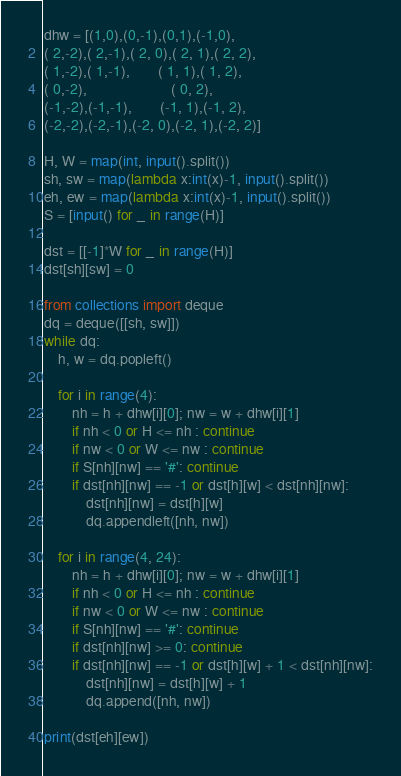Convert code to text. <code><loc_0><loc_0><loc_500><loc_500><_Python_>dhw = [(1,0),(0,-1),(0,1),(-1,0),
( 2,-2),( 2,-1),( 2, 0),( 2, 1),( 2, 2),
( 1,-2),( 1,-1),        ( 1, 1),( 1, 2),
( 0,-2),                        ( 0, 2),
(-1,-2),(-1,-1),        (-1, 1),(-1, 2),
(-2,-2),(-2,-1),(-2, 0),(-2, 1),(-2, 2)]

H, W = map(int, input().split())
sh, sw = map(lambda x:int(x)-1, input().split())
eh, ew = map(lambda x:int(x)-1, input().split())
S = [input() for _ in range(H)]

dst = [[-1]*W for _ in range(H)]
dst[sh][sw] = 0

from collections import deque
dq = deque([[sh, sw]])
while dq:
    h, w = dq.popleft()

    for i in range(4):
        nh = h + dhw[i][0]; nw = w + dhw[i][1]
        if nh < 0 or H <= nh : continue
        if nw < 0 or W <= nw : continue
        if S[nh][nw] == '#': continue
        if dst[nh][nw] == -1 or dst[h][w] < dst[nh][nw]:
            dst[nh][nw] = dst[h][w]
            dq.appendleft([nh, nw])

    for i in range(4, 24):
        nh = h + dhw[i][0]; nw = w + dhw[i][1]
        if nh < 0 or H <= nh : continue
        if nw < 0 or W <= nw : continue
        if S[nh][nw] == '#': continue
        if dst[nh][nw] >= 0: continue
        if dst[nh][nw] == -1 or dst[h][w] + 1 < dst[nh][nw]:
            dst[nh][nw] = dst[h][w] + 1
            dq.append([nh, nw])

print(dst[eh][ew])
</code> 